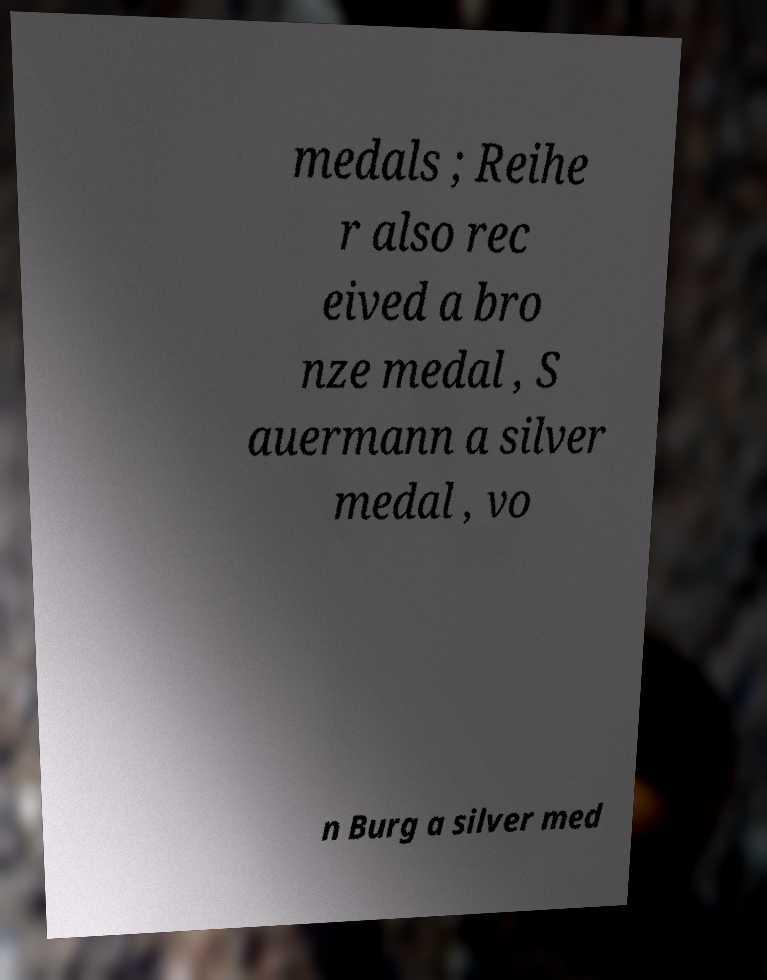Can you accurately transcribe the text from the provided image for me? medals ; Reihe r also rec eived a bro nze medal , S auermann a silver medal , vo n Burg a silver med 